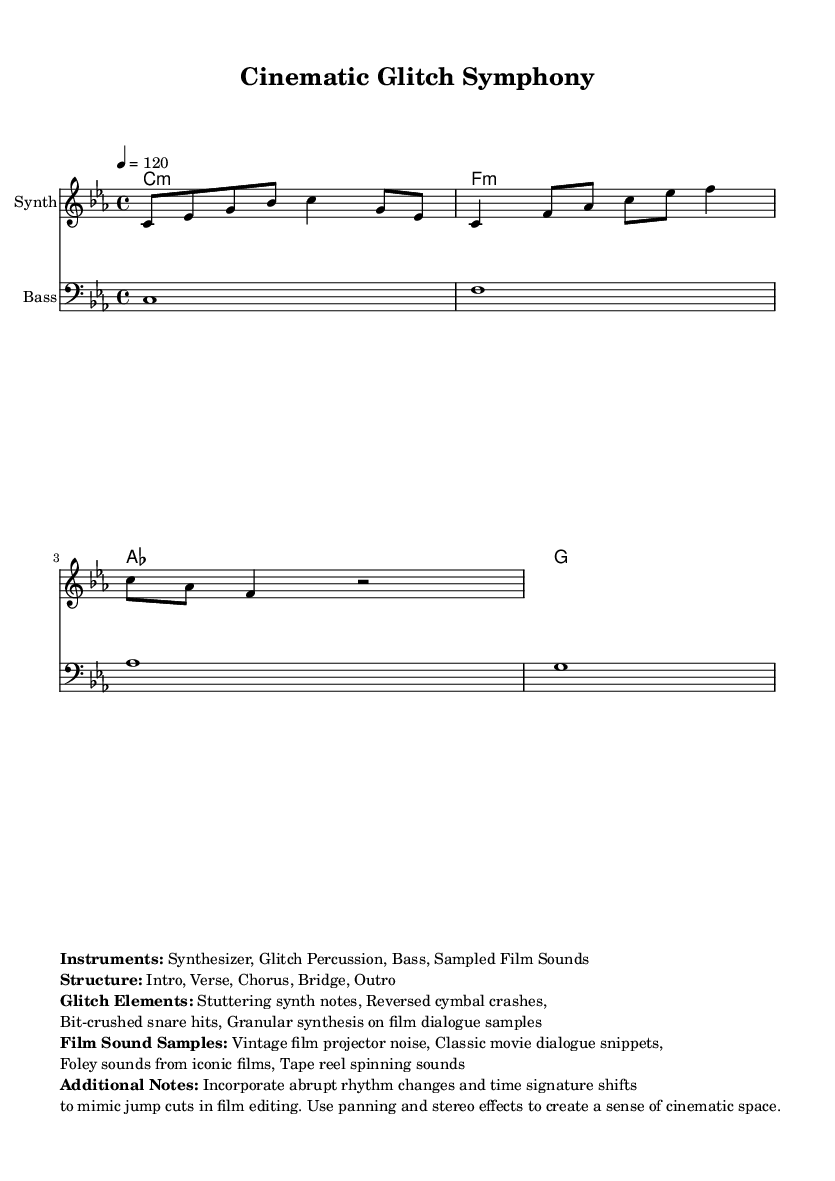What is the key signature of this music? The key signature is indicated at the beginning of the score. In this case, it shows that the piece is in C minor, which has three flats in its key signature (B♭, E♭, A♭).
Answer: C minor What is the time signature of this music? The time signature appears at the beginning of the score, showing that the piece is written in 4/4 timing, meaning there are four beats in each measure and the quarter note gets one beat.
Answer: 4/4 What is the tempo marking of this music? The tempo marking is specified at the beginning of the score, indicating the speed of the piece. Here, it states that the tempo is set to 120 beats per minute, which is a moderate pace.
Answer: 120 How many measures does the melody have? By counting the individual segments between the vertical bar lines in the melody section, we find that there are four measures total in the melody line provided.
Answer: 4 What type of instruments are used in this piece? The instruments are listed in the markup section of the score, which includes Synthesizer and Bass, as well as electronic elements like Glitch Percussion.
Answer: Synthesizer, Bass What is one characteristic of the "Glitch Elements" mentioned in this music? The "Glitch Elements" are noted in the markup and consist of features that manipulate sound, such as stuttering synth notes, which contribute to a fragmented auditory experience.
Answer: Stuttering synth notes What structural sections are present in this music? The structure is explicitly detailed in the markup, listing various sections such as Intro, Verse, Chorus, Bridge, and Outro, indicating how the music is organized over its duration.
Answer: Intro, Verse, Chorus, Bridge, Outro 